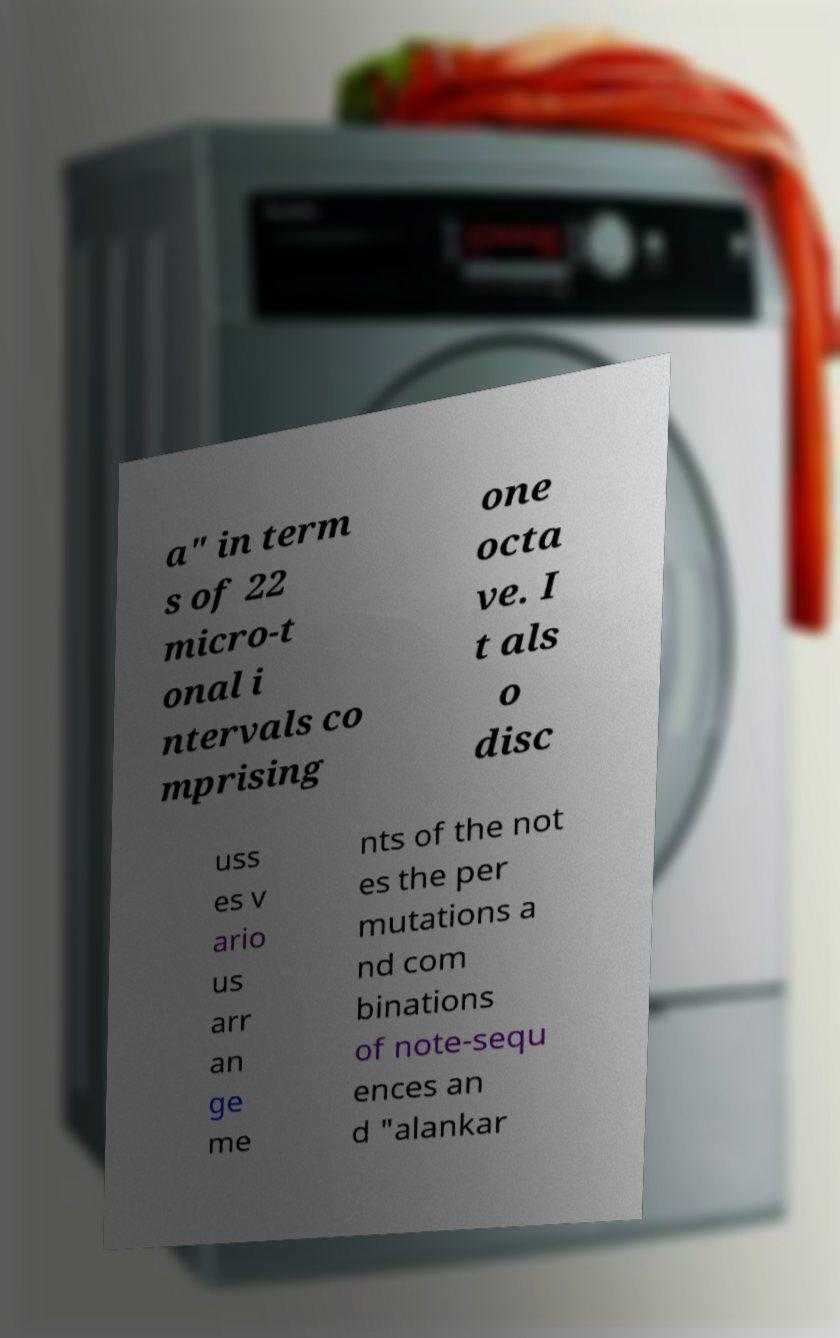Could you assist in decoding the text presented in this image and type it out clearly? a" in term s of 22 micro-t onal i ntervals co mprising one octa ve. I t als o disc uss es v ario us arr an ge me nts of the not es the per mutations a nd com binations of note-sequ ences an d "alankar 